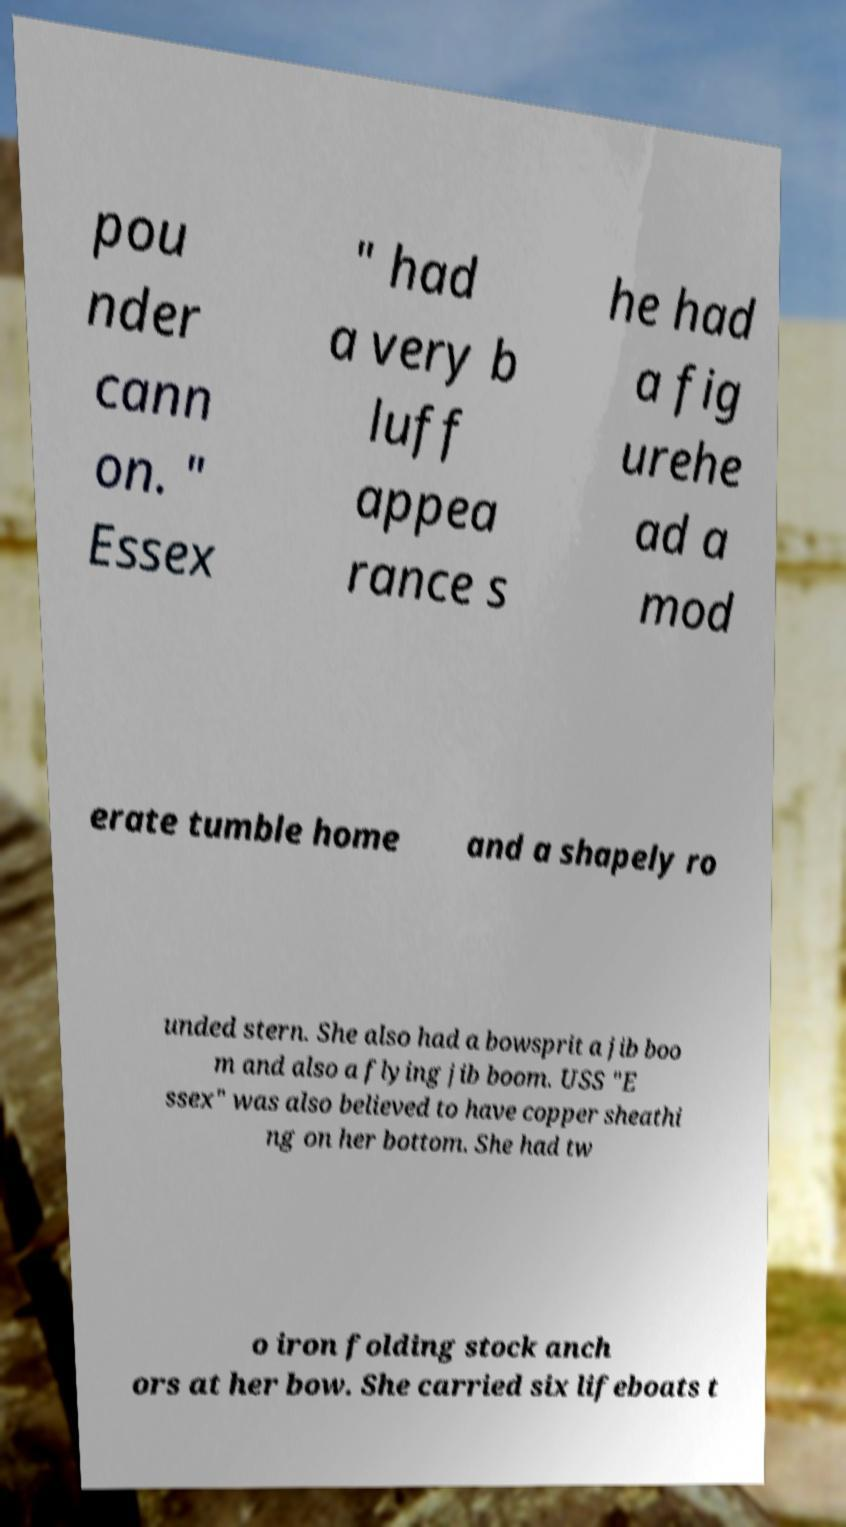Can you read and provide the text displayed in the image?This photo seems to have some interesting text. Can you extract and type it out for me? pou nder cann on. " Essex " had a very b luff appea rance s he had a fig urehe ad a mod erate tumble home and a shapely ro unded stern. She also had a bowsprit a jib boo m and also a flying jib boom. USS "E ssex" was also believed to have copper sheathi ng on her bottom. She had tw o iron folding stock anch ors at her bow. She carried six lifeboats t 